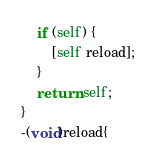<code> <loc_0><loc_0><loc_500><loc_500><_ObjectiveC_>    if (self) {
        [self reload];
    }
    return self;
}
-(void)reload{</code> 